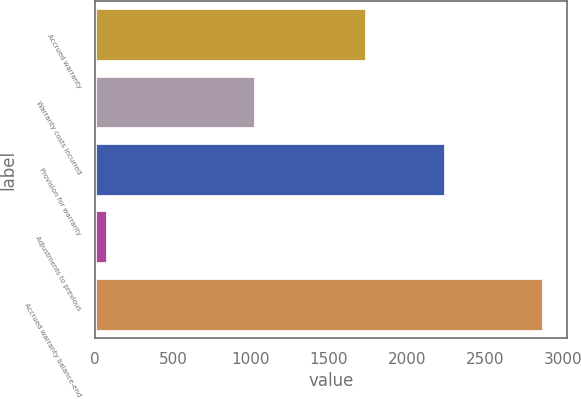<chart> <loc_0><loc_0><loc_500><loc_500><bar_chart><fcel>Accrued warranty<fcel>Warranty costs incurred<fcel>Provision for warranty<fcel>Adjustments to previous<fcel>Accrued warranty balance-end<nl><fcel>1744<fcel>1030<fcel>2252<fcel>84<fcel>2882<nl></chart> 